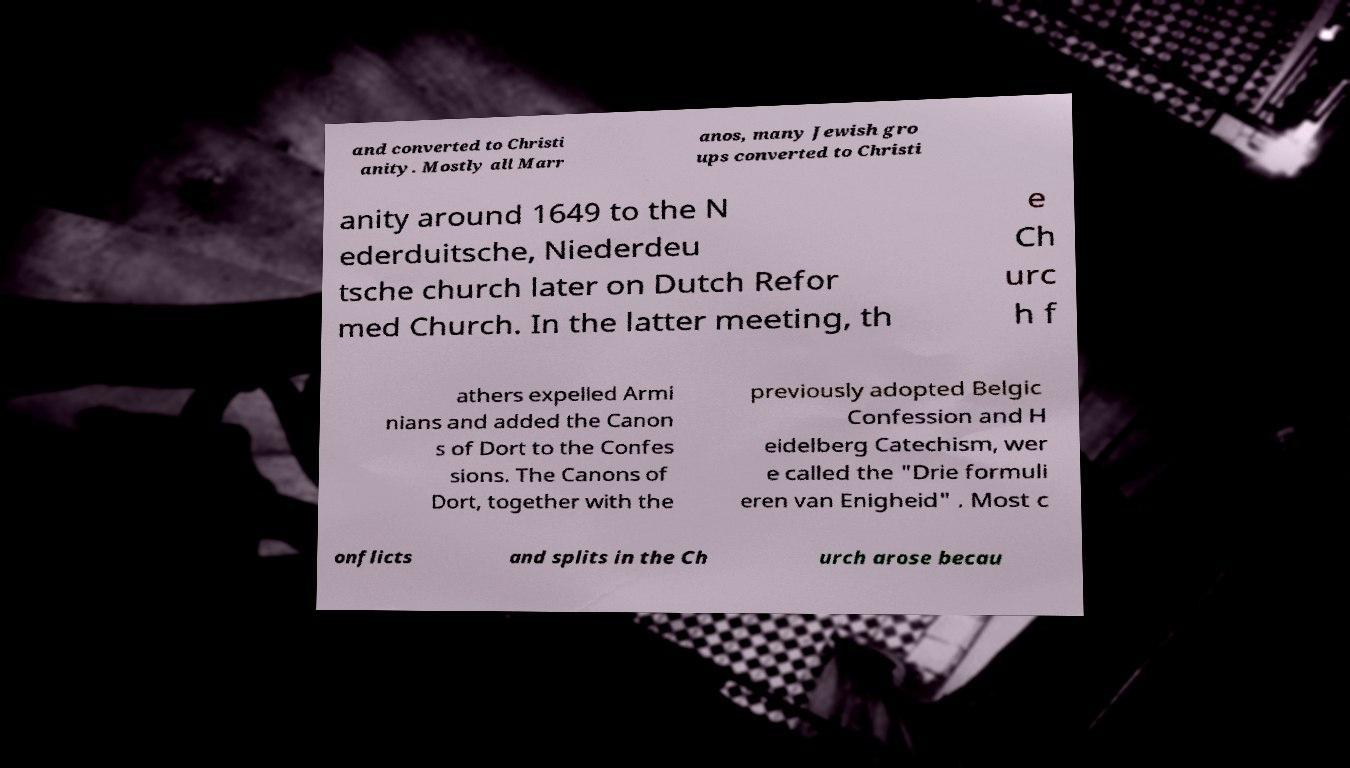I need the written content from this picture converted into text. Can you do that? and converted to Christi anity. Mostly all Marr anos, many Jewish gro ups converted to Christi anity around 1649 to the N ederduitsche, Niederdeu tsche church later on Dutch Refor med Church. In the latter meeting, th e Ch urc h f athers expelled Armi nians and added the Canon s of Dort to the Confes sions. The Canons of Dort, together with the previously adopted Belgic Confession and H eidelberg Catechism, wer e called the "Drie formuli eren van Enigheid" . Most c onflicts and splits in the Ch urch arose becau 